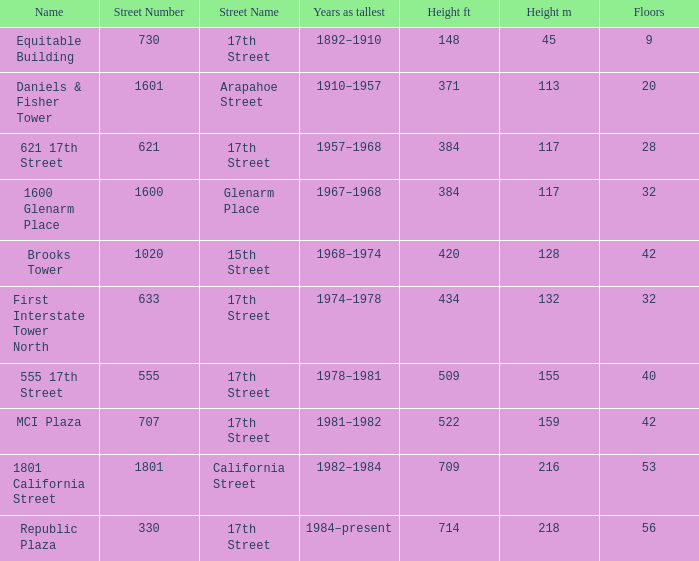What is the height of the building with 40 floors? 509 / 155. 